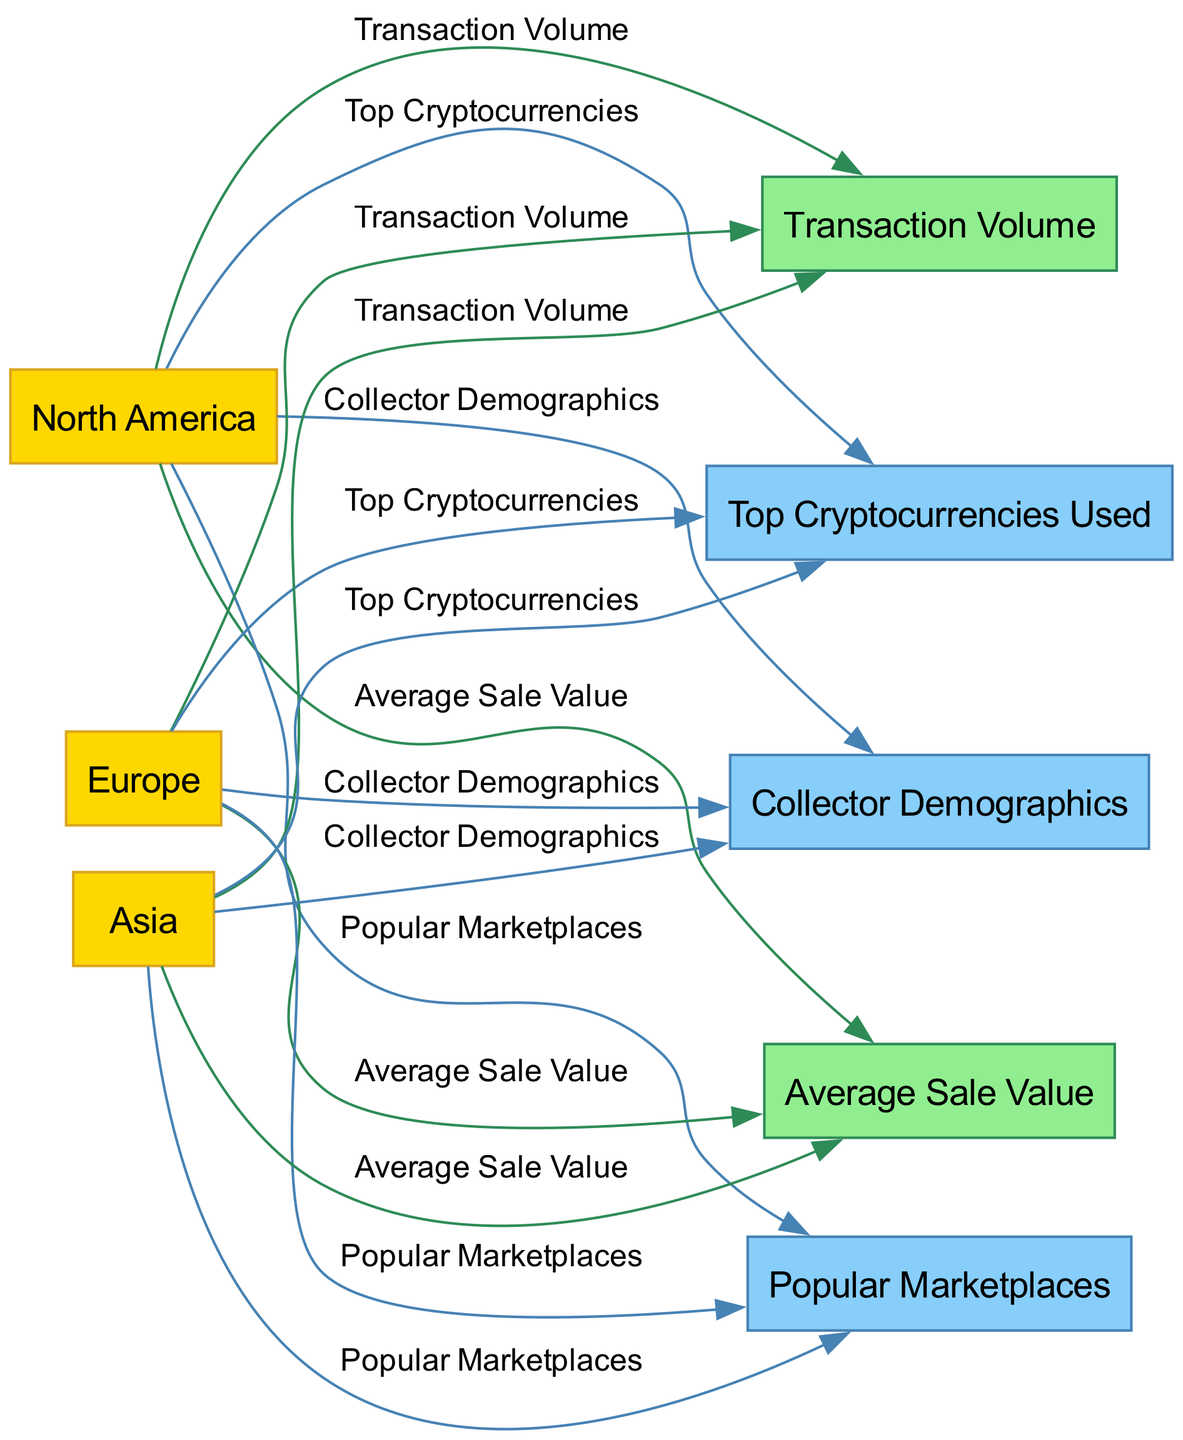What regions are compared in the diagram? The diagram specifically compares three regions: North America, Europe, and Asia. These regions are consistently categorized as nodes in the visual presented.
Answer: North America, Europe, Asia Which metric is connected to all regions? Looking at the edges in the diagram, "Transaction Volume" serves as a metric that connects all three regions, as each region has a direct edge pointing to this metric node.
Answer: Transaction Volume What is the relationship between North America and Top Cryptocurrencies Used? The diagram shows a direct edge from North America to the node "Top Cryptocurrencies Used," indicating a direct relationship, meaning North America contributes specific cryptocurrencies in the art sales market.
Answer: Direct relationship How many factors are identified in the diagram? The diagram outlines several factors associated with the regions, specifically identifying "Top Cryptocurrencies Used," "Popular Marketplaces," and "Collector Demographics." By counting these nodes, we determine the total count of factors represented.
Answer: Three Which region has the highest Average Sale Value? To answer this, one would analyze the edges connected to the metric "Average Sale Value" from each region. Without the visual data, one might have to infer based on common trends; yet all three regions connect, indicating that each probably has differing values.
Answer: (Requires visual inspection for actual value) Why is "Collector Demographics" connected to all regions? The diagram illustrates that "Collector Demographics" is a factor that illuminates the characteristics of art collectors across each of the regions. This indicates that the demographics may differ in each area yet are a crucial aspect influencing the art sales transactions.
Answer: Influences transactions What does the edge color signify between regions and metrics? The color of the edges, which is green for metrics and blue for factors, indicates the type of relationship. As metrics represent quantifiable data, they're shown as green. In contrast, factors, which are conceptual variables, are presented in blue to differentiate their nature.
Answer: Green for metrics, blue for factors Which region is likely to have the most diverse marketplaces based on the diagram? By looking at the connections to "Popular Marketplaces," you can analyze which region might have the most extensive ecosystem in terms of the number of marketplace connections, although this requires detailed inspection of edge connections in the visual representation to assess diversity correctly.
Answer: (Requires visual inspection for actual determination) 